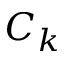Convert formula to latex. <formula><loc_0><loc_0><loc_500><loc_500>C _ { k }</formula> 